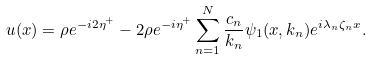Convert formula to latex. <formula><loc_0><loc_0><loc_500><loc_500>u ( x ) = \rho e ^ { - i 2 \eta ^ { + } } - 2 \rho e ^ { - i \eta ^ { + } } \sum _ { n = 1 } ^ { N } \frac { c _ { n } } { k _ { n } } \psi _ { 1 } ( x , k _ { n } ) e ^ { i \lambda _ { n } \zeta _ { n } x } .</formula> 